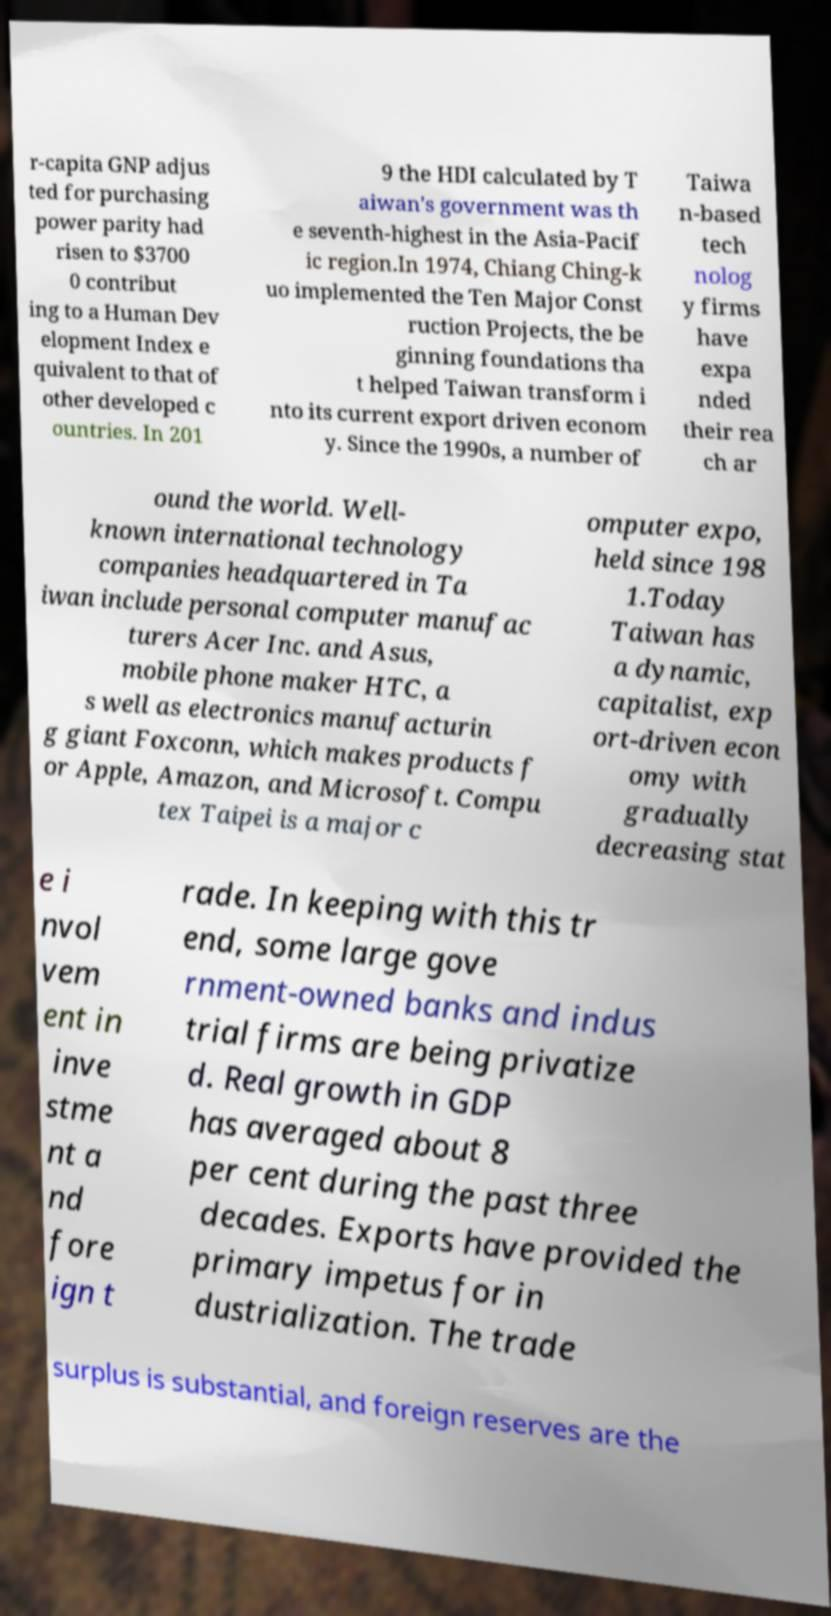For documentation purposes, I need the text within this image transcribed. Could you provide that? r-capita GNP adjus ted for purchasing power parity had risen to $3700 0 contribut ing to a Human Dev elopment Index e quivalent to that of other developed c ountries. In 201 9 the HDI calculated by T aiwan's government was th e seventh-highest in the Asia-Pacif ic region.In 1974, Chiang Ching-k uo implemented the Ten Major Const ruction Projects, the be ginning foundations tha t helped Taiwan transform i nto its current export driven econom y. Since the 1990s, a number of Taiwa n-based tech nolog y firms have expa nded their rea ch ar ound the world. Well- known international technology companies headquartered in Ta iwan include personal computer manufac turers Acer Inc. and Asus, mobile phone maker HTC, a s well as electronics manufacturin g giant Foxconn, which makes products f or Apple, Amazon, and Microsoft. Compu tex Taipei is a major c omputer expo, held since 198 1.Today Taiwan has a dynamic, capitalist, exp ort-driven econ omy with gradually decreasing stat e i nvol vem ent in inve stme nt a nd fore ign t rade. In keeping with this tr end, some large gove rnment-owned banks and indus trial firms are being privatize d. Real growth in GDP has averaged about 8 per cent during the past three decades. Exports have provided the primary impetus for in dustrialization. The trade surplus is substantial, and foreign reserves are the 